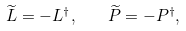<formula> <loc_0><loc_0><loc_500><loc_500>\widetilde { L } = - L ^ { \dagger } , \quad \widetilde { P } = - P ^ { \dagger } ,</formula> 